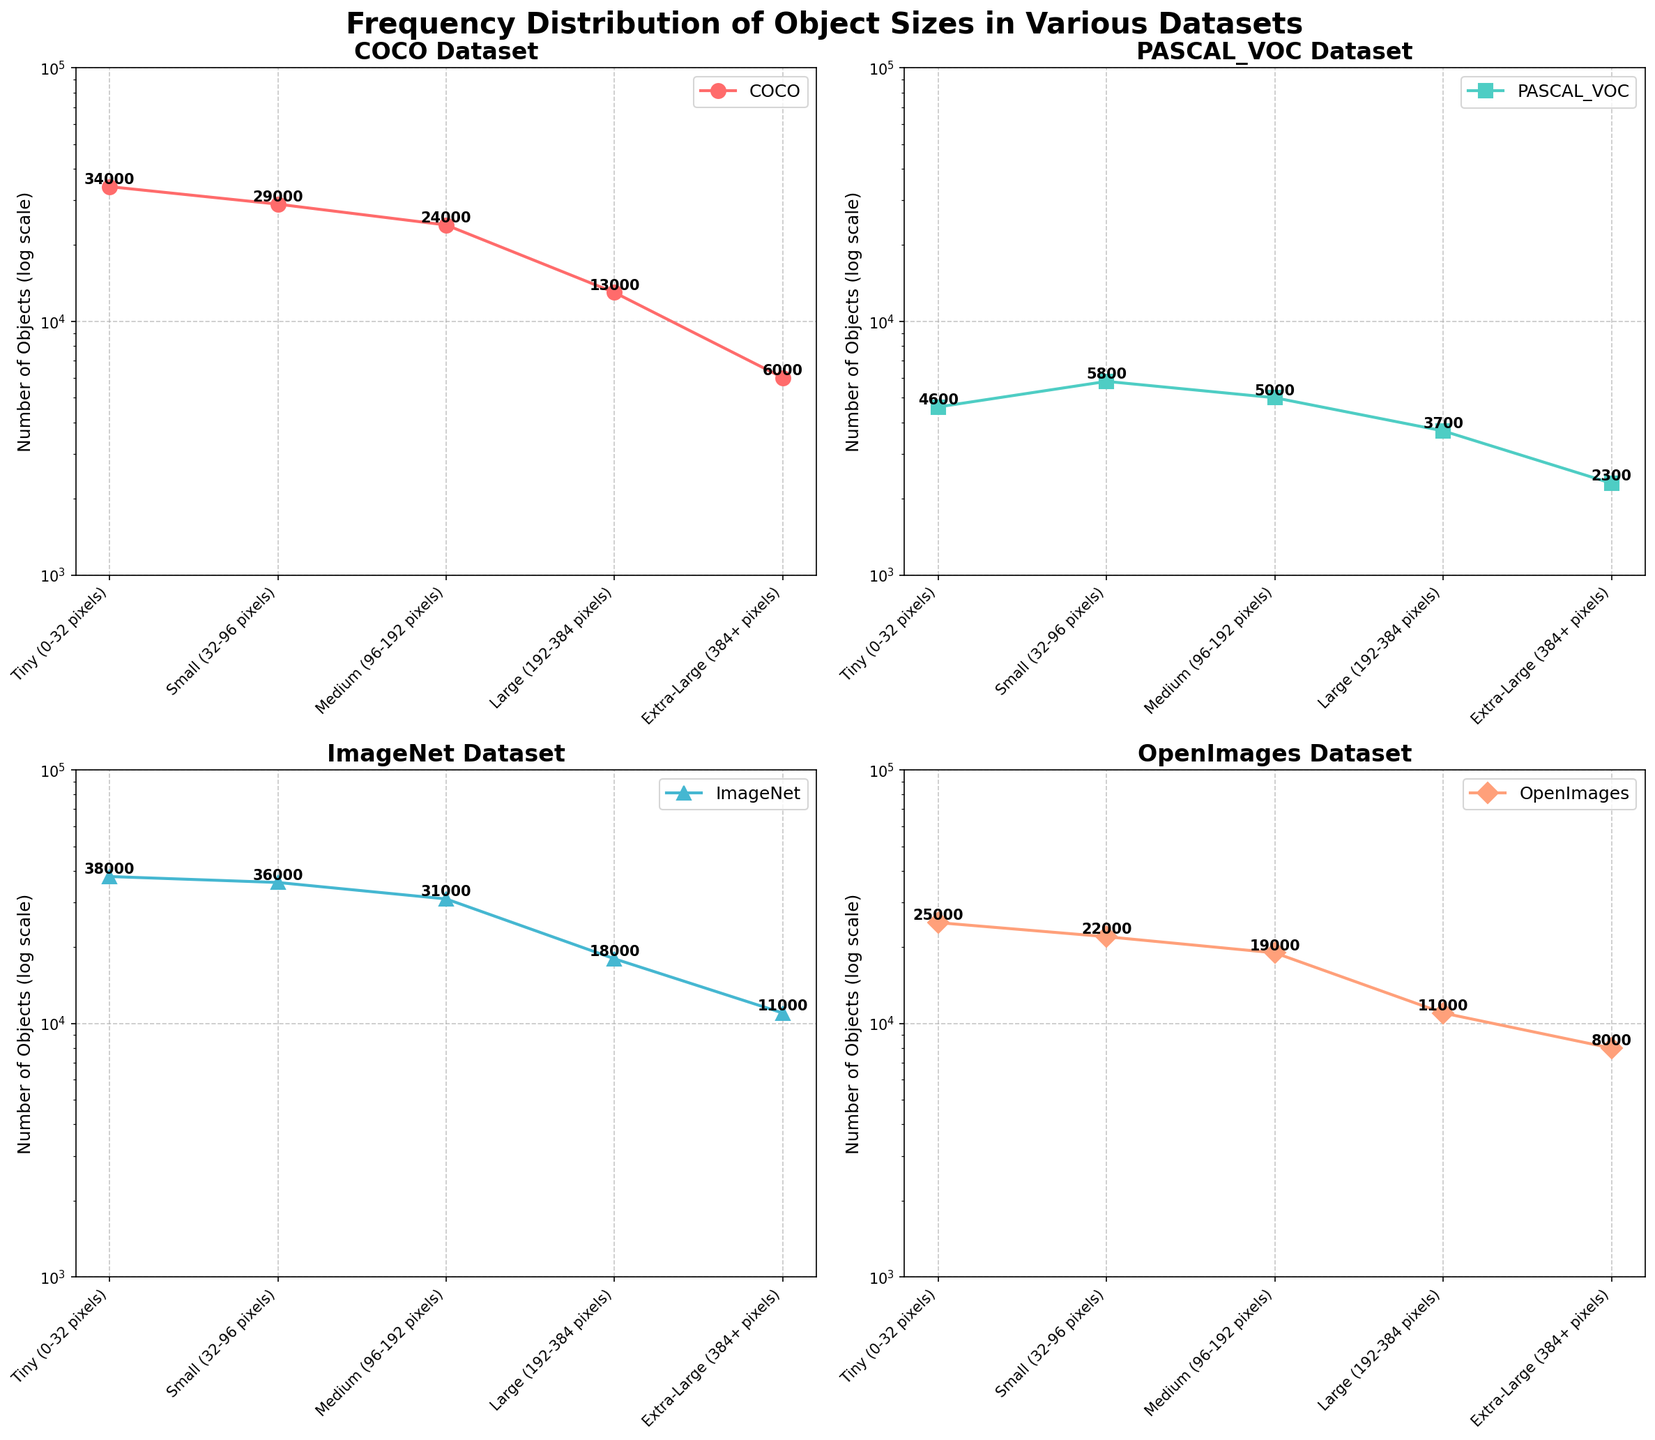Which dataset has the highest number of tiny objects? The tiny object category is shown in the first position on the x-axis in each subplot. Review each subplot to see which dataset's line reaches the highest point on the y-axis (log scale) for tiny objects. For COCO, it's 34,000, which is the highest among all datasets.
Answer: COCO How many datasets have more than 20,000 objects in the small category? The small object category is the second position on the x-axis. For each dataset, check the y-value for this category and count the number of datasets with values over 20,000. COCO and ImageNet both exceed 20,000 for small objects, OpenImages also.
Answer: 3 Which dataset has the smallest number of extra-large objects? The extra-large object category is the last position on the x-axis. Compare each dataset's y-value for this category and pick the smallest one. PASCAL VOC has 2,300 extra-large objects, the smallest among all datasets.
Answer: PASCAL VOC What is the difference in the number of medium objects between COCO and PASCAL VOC datasets? Locate the medium object category on the x-axis. Find the y-values for the medium objects in both COCO (24,000) and PASCAL VOC (5,000). Subtract PASCAL VOC's value from COCO's value. 24,000 - 5,000 = 19,000
Answer: 19,000 Which dataset has the most significant drop in object count from the small to large size categories? Compare the y-values between the small and large categories for each dataset. Calculate the difference and identify which dataset has the highest drop. ImageNet goes from 36,000 (small) to 18,000 (large), a drop of 18,000.
Answer: ImageNet In terms of the number of large objects, how do OpenImages and ImageNet compare? Locate the large object category on the x-axis and compare the y-values for OpenImages (11,000) and ImageNet (18,000). ImageNet has more large objects than OpenImages.
Answer: ImageNet has more What is the average number of tiny objects across all four datasets? Add the number of tiny objects for all datasets and divide by the number of datasets. (34,000 + 4,600 + 38,000 + 25,000) / 4 = 25,900
Answer: 25,900 Do any datasets have more medium-sized objects than small-sized objects? Compare the y-values for the small and medium object categories for each dataset. None of the datasets have a higher count for medium objects compared to small objects.
Answer: No Which object size category is consistently the smallest across all datasets? For each size category, identify the dataset with the smallest number of objects and compare these minimum values across categories. Extra-large objects are consistently the smallest category in terms of number.
Answer: Extra-large How does the number of small objects in COCO compare to PASCAL VOC? Locate the small object category for both COCO and PASCAL VOC. COCO has 29,000 small objects while PASCAL VOC has 5,800. COCO has significantly more small objects.
Answer: COCO has more 